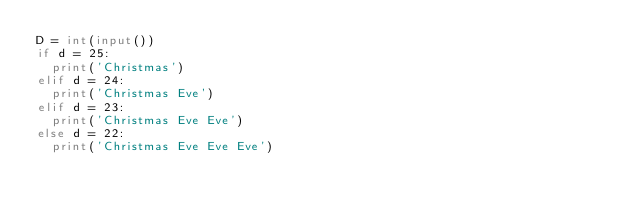<code> <loc_0><loc_0><loc_500><loc_500><_Python_>D = int(input())
if d = 25:
  print('Christmas')
elif d = 24:
  print('Christmas Eve')
elif d = 23:
  print('Christmas Eve Eve')
else d = 22:
  print('Christmas Eve Eve Eve')</code> 